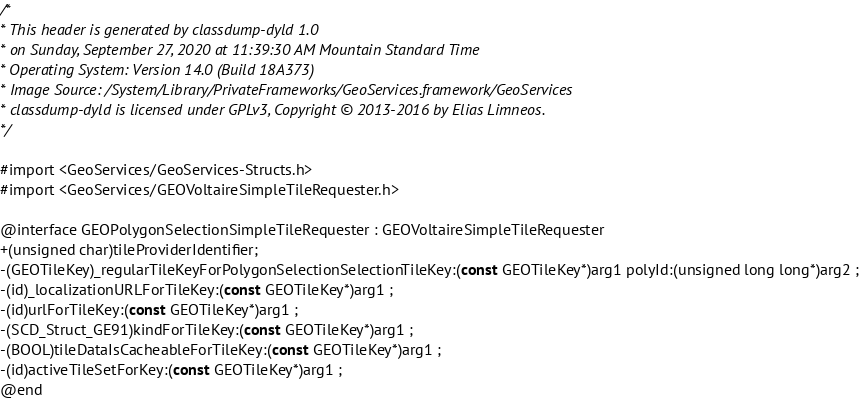<code> <loc_0><loc_0><loc_500><loc_500><_C_>/*
* This header is generated by classdump-dyld 1.0
* on Sunday, September 27, 2020 at 11:39:30 AM Mountain Standard Time
* Operating System: Version 14.0 (Build 18A373)
* Image Source: /System/Library/PrivateFrameworks/GeoServices.framework/GeoServices
* classdump-dyld is licensed under GPLv3, Copyright © 2013-2016 by Elias Limneos.
*/

#import <GeoServices/GeoServices-Structs.h>
#import <GeoServices/GEOVoltaireSimpleTileRequester.h>

@interface GEOPolygonSelectionSimpleTileRequester : GEOVoltaireSimpleTileRequester
+(unsigned char)tileProviderIdentifier;
-(GEOTileKey)_regularTileKeyForPolygonSelectionSelectionTileKey:(const GEOTileKey*)arg1 polyId:(unsigned long long*)arg2 ;
-(id)_localizationURLForTileKey:(const GEOTileKey*)arg1 ;
-(id)urlForTileKey:(const GEOTileKey*)arg1 ;
-(SCD_Struct_GE91)kindForTileKey:(const GEOTileKey*)arg1 ;
-(BOOL)tileDataIsCacheableForTileKey:(const GEOTileKey*)arg1 ;
-(id)activeTileSetForKey:(const GEOTileKey*)arg1 ;
@end

</code> 